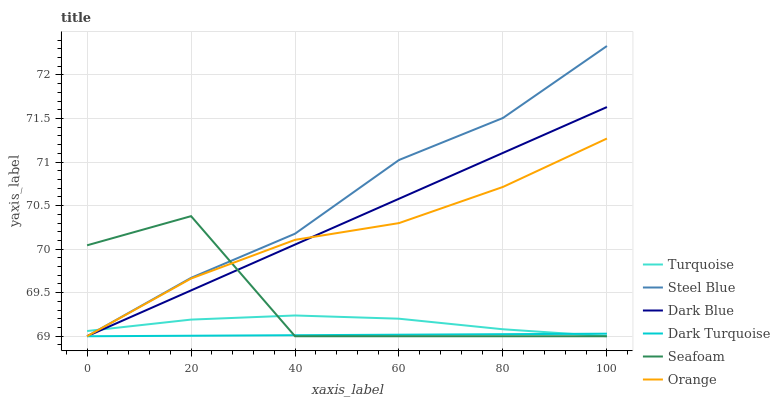Does Dark Turquoise have the minimum area under the curve?
Answer yes or no. Yes. Does Steel Blue have the maximum area under the curve?
Answer yes or no. Yes. Does Seafoam have the minimum area under the curve?
Answer yes or no. No. Does Seafoam have the maximum area under the curve?
Answer yes or no. No. Is Dark Turquoise the smoothest?
Answer yes or no. Yes. Is Seafoam the roughest?
Answer yes or no. Yes. Is Seafoam the smoothest?
Answer yes or no. No. Is Dark Turquoise the roughest?
Answer yes or no. No. Does Turquoise have the lowest value?
Answer yes or no. Yes. Does Steel Blue have the highest value?
Answer yes or no. Yes. Does Seafoam have the highest value?
Answer yes or no. No. Does Orange intersect Steel Blue?
Answer yes or no. Yes. Is Orange less than Steel Blue?
Answer yes or no. No. Is Orange greater than Steel Blue?
Answer yes or no. No. 